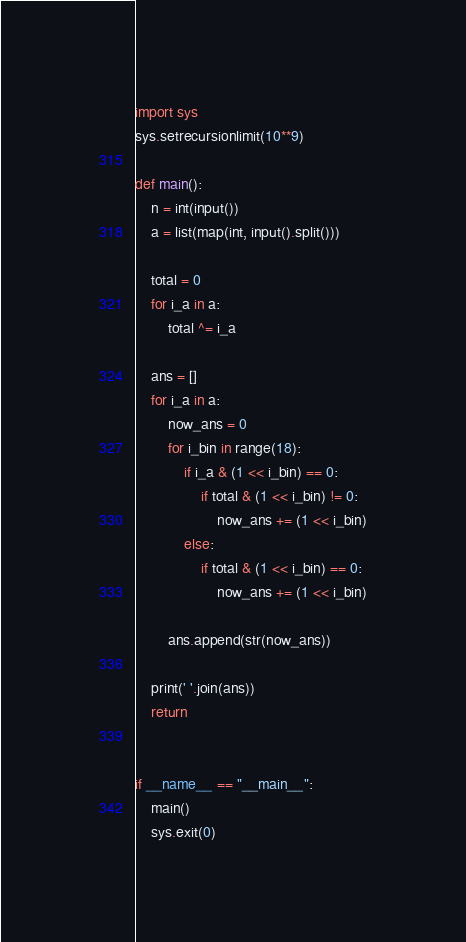Convert code to text. <code><loc_0><loc_0><loc_500><loc_500><_Python_>import sys
sys.setrecursionlimit(10**9)

def main():
    n = int(input())
    a = list(map(int, input().split()))
    
    total = 0
    for i_a in a:
        total ^= i_a

    ans = []
    for i_a in a:
        now_ans = 0
        for i_bin in range(18):
            if i_a & (1 << i_bin) == 0:
                if total & (1 << i_bin) != 0:
                    now_ans += (1 << i_bin)
            else:
                if total & (1 << i_bin) == 0:
                    now_ans += (1 << i_bin)

        ans.append(str(now_ans))

    print(' '.join(ans))
    return


if __name__ == "__main__":
    main()
    sys.exit(0)</code> 